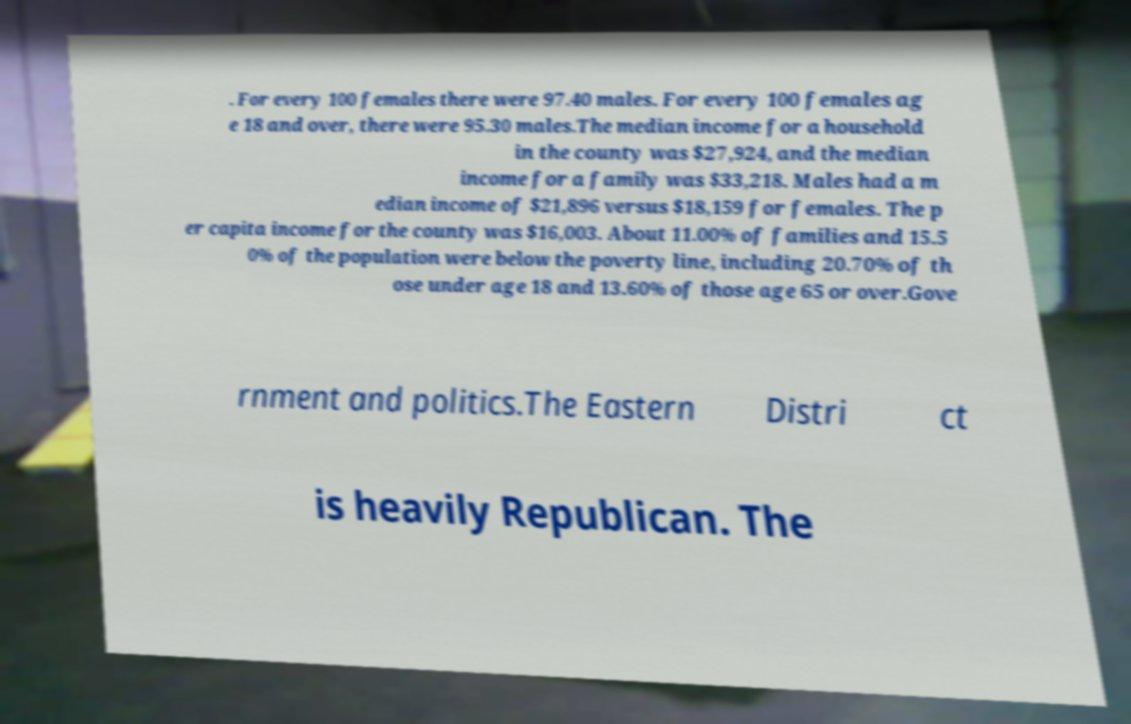Please identify and transcribe the text found in this image. . For every 100 females there were 97.40 males. For every 100 females ag e 18 and over, there were 95.30 males.The median income for a household in the county was $27,924, and the median income for a family was $33,218. Males had a m edian income of $21,896 versus $18,159 for females. The p er capita income for the county was $16,003. About 11.00% of families and 15.5 0% of the population were below the poverty line, including 20.70% of th ose under age 18 and 13.60% of those age 65 or over.Gove rnment and politics.The Eastern Distri ct is heavily Republican. The 